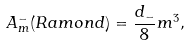<formula> <loc_0><loc_0><loc_500><loc_500>A _ { m } ^ { - } ( R a m o n d ) = \frac { d _ { - } } { 8 } m ^ { 3 } ,</formula> 